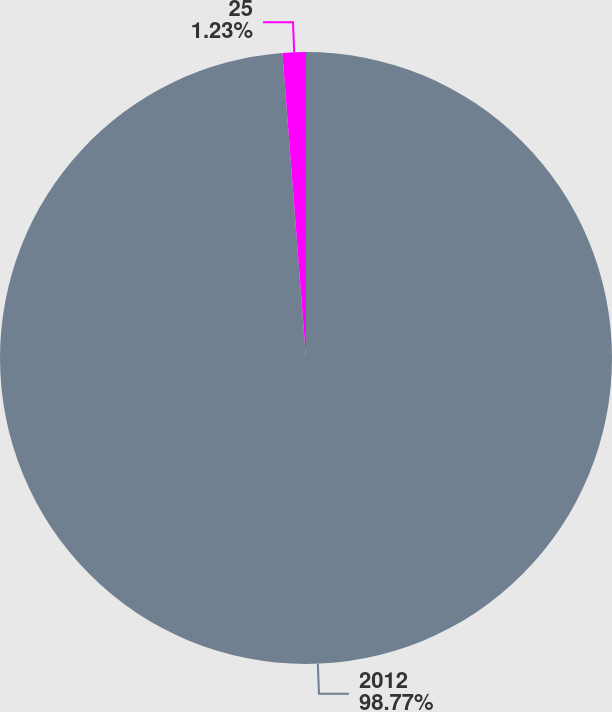Convert chart. <chart><loc_0><loc_0><loc_500><loc_500><pie_chart><fcel>2012<fcel>25<nl><fcel>98.77%<fcel>1.23%<nl></chart> 